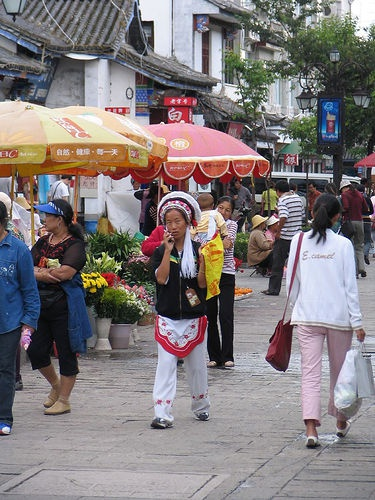Describe the objects in this image and their specific colors. I can see people in gray, lavender, darkgray, and black tones, people in gray, black, darkgray, lavender, and brown tones, people in gray, black, navy, and maroon tones, umbrella in gray, beige, tan, and olive tones, and umbrella in gray, lightpink, maroon, and brown tones in this image. 